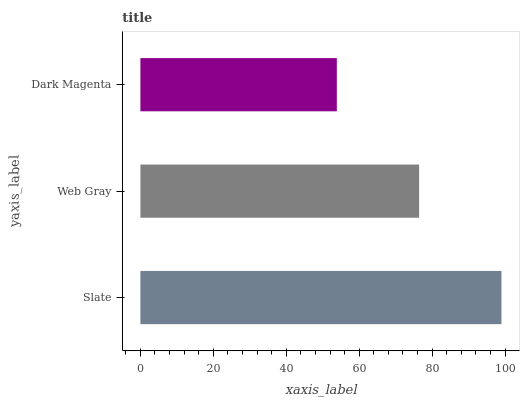Is Dark Magenta the minimum?
Answer yes or no. Yes. Is Slate the maximum?
Answer yes or no. Yes. Is Web Gray the minimum?
Answer yes or no. No. Is Web Gray the maximum?
Answer yes or no. No. Is Slate greater than Web Gray?
Answer yes or no. Yes. Is Web Gray less than Slate?
Answer yes or no. Yes. Is Web Gray greater than Slate?
Answer yes or no. No. Is Slate less than Web Gray?
Answer yes or no. No. Is Web Gray the high median?
Answer yes or no. Yes. Is Web Gray the low median?
Answer yes or no. Yes. Is Dark Magenta the high median?
Answer yes or no. No. Is Slate the low median?
Answer yes or no. No. 